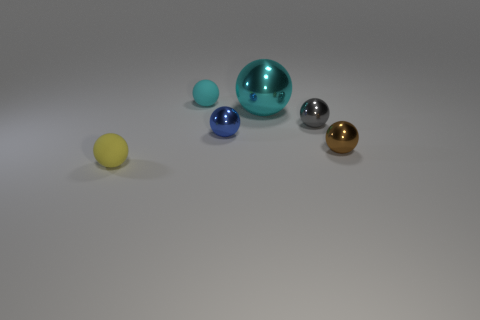There is a yellow ball that is left of the small rubber thing on the right side of the small matte thing in front of the small brown ball; what is it made of?
Your response must be concise. Rubber. There is a ball that is on the right side of the tiny blue metallic sphere and on the left side of the gray thing; how big is it?
Keep it short and to the point. Large. Does the brown metal object have the same shape as the tiny yellow thing?
Keep it short and to the point. Yes. What shape is the big cyan thing that is the same material as the tiny brown sphere?
Your response must be concise. Sphere. What number of small objects are either brown objects or blue spheres?
Keep it short and to the point. 2. There is a small ball left of the small cyan object; is there a gray ball that is in front of it?
Ensure brevity in your answer.  No. Is there a ball?
Your response must be concise. Yes. What color is the thing that is in front of the ball that is right of the gray shiny ball?
Make the answer very short. Yellow. There is a brown object that is the same shape as the tiny gray metal object; what is it made of?
Your answer should be very brief. Metal. How many yellow things have the same size as the yellow rubber ball?
Provide a short and direct response. 0. 